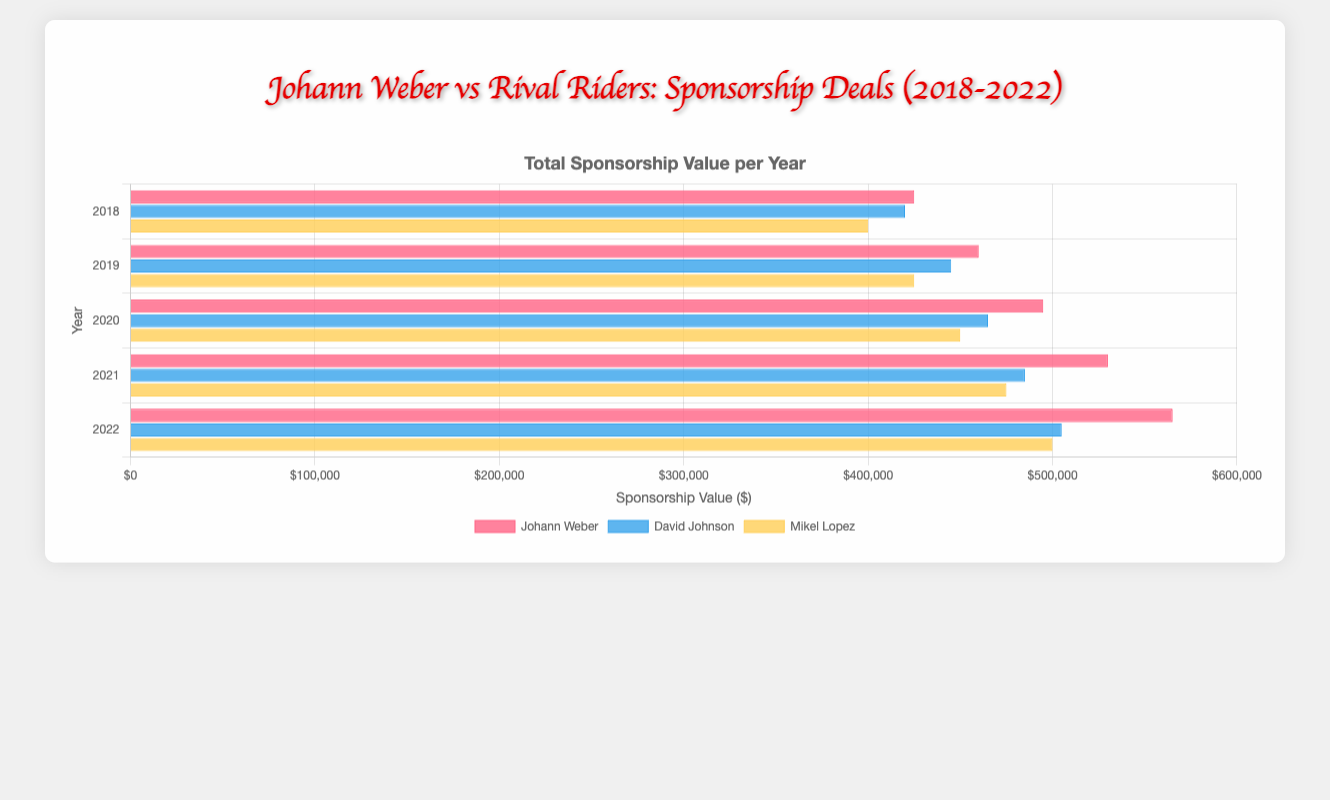Which rider had the highest total sponsorship value in 2020? The sponsorship values for 2020 are: Johann Weber with $495,000, David Johnson with $465,000, and Mikel Lopez with $450,000. Johann Weber's value is the highest.
Answer: Johann Weber What is the total combined sponsorship value for Johann Weber from 2018 to 2022? Summing up Johann Weber's sponsorship values from each year: $425,000 (2018) + $460,000 (2019) + $495,000 (2020) + $530,000 (2021) + $565,000 (2022) gives a total of $2,475,000.
Answer: $2,475,000 Between David Johnson and Mikel Lopez, who saw a bigger increase in sponsorship value from 2018 to 2022? David Johnson's increase: $505,000 (2022) - $420,000 (2018) = $85,000. Mikel Lopez's increase: $500,000 (2022) - $400,000 (2018) = $100,000. Mikel Lopez has a bigger increase.
Answer: Mikel Lopez In which year did Johann Weber have the smallest total sponsorship value and what was it? Johann Weber's smallest total sponsorship value was in 2018, with a value of $425,000.
Answer: 2018, $425,000 What is the average annual sponsorship value of Monster Energy for Johann Weber from 2018 to 2022? Monster Energy sponsorship values for Johann Weber: $150,000 (2018), $160,000 (2019), $170,000 (2020), $180,000 (2021), $190,000 (2022). The average is (150,000 + 160,000 + 170,000 + 180,000 + 190,000) / 5 = $170,000.
Answer: $170,000 Who had more sponsorship from 2018 to 2022, David Johnson or Mikel Lopez, and by how much? Total for David Johnson: $420,000 (2018) + $445,000 (2019) + $465,000 (2020) + $485,000 (2021) + $505,000 (2022) = $2,320,000. Total for Mikel Lopez: $400,000 (2018) + $425,000 (2019) + $450,000 (2020) + $475,000 (2021) + $500,000 (2022) = $2,250,000. Difference is $2,320,000 - $2,250,000 = $70,000.
Answer: David Johnson, $70,000 What is the percentage increase in Johann Weber's total sponsorship value from 2018 to 2022? John's value in 2018: $425,000. In 2022: $565,000. The increase: $565,000 - $425,000 = $140,000. The percentage increase is ($140,000 / $425,000) * 100% = approximately 32.94%.
Answer: 32.94% Which rider had the least sponsorship in 2021, and what was the value? For 2021: Johann Weber $530,000, David Johnson $485,000, Mikel Lopez $475,000. Mikel Lopez had the least with $475,000.
Answer: Mikel Lopez, $475,000 